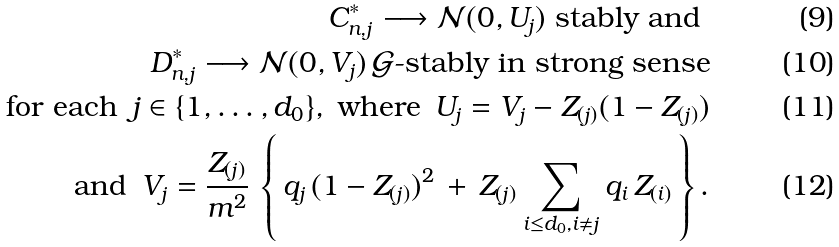Convert formula to latex. <formula><loc_0><loc_0><loc_500><loc_500>C _ { n , j } ^ { * } \longrightarrow \mathcal { N } ( 0 , U _ { j } ) \text { stably and } \\ D _ { n , j } ^ { * } \longrightarrow \mathcal { N } ( 0 , V _ { j } ) \, \mathcal { G } \text {-stably in strong sense} \\ \text {for each } \, j \in \{ 1 , \dots , d _ { 0 } \} , \text { where } \, U _ { j } = V _ { j } - Z _ { ( j ) } ( 1 - Z _ { ( j ) } ) \\ \text {and } \, V _ { j } = \frac { Z _ { ( j ) } } { m ^ { 2 } } \, \left \{ \, q _ { j } \, ( 1 - Z _ { ( j ) } ) ^ { 2 } \, + \, Z _ { ( j ) } \sum _ { i \leq d _ { 0 } , i \neq j } q _ { i } \, Z _ { ( i ) } \, \right \} .</formula> 